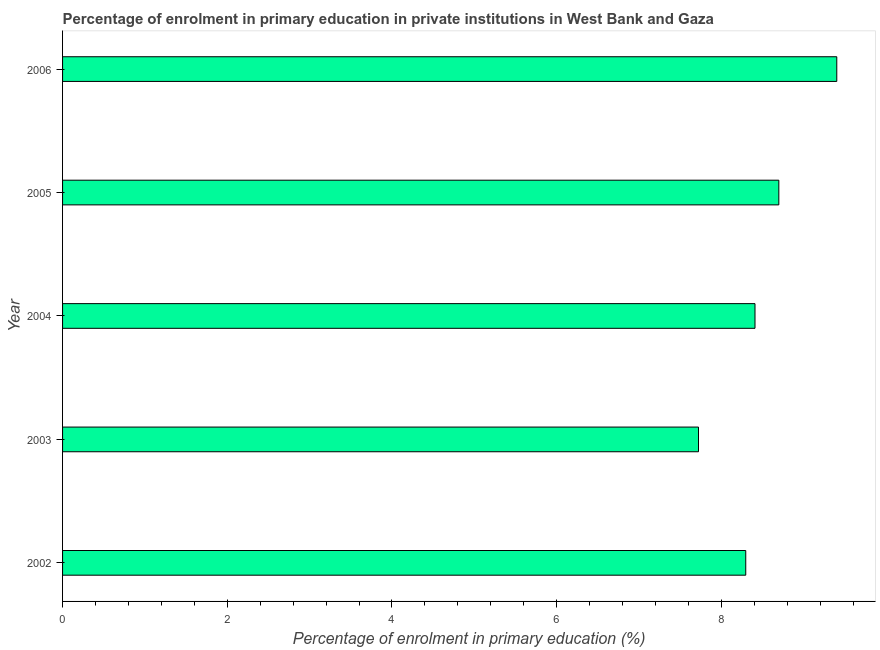Does the graph contain any zero values?
Your answer should be compact. No. What is the title of the graph?
Offer a very short reply. Percentage of enrolment in primary education in private institutions in West Bank and Gaza. What is the label or title of the X-axis?
Provide a succinct answer. Percentage of enrolment in primary education (%). What is the enrolment percentage in primary education in 2002?
Your answer should be very brief. 8.3. Across all years, what is the maximum enrolment percentage in primary education?
Provide a succinct answer. 9.4. Across all years, what is the minimum enrolment percentage in primary education?
Offer a very short reply. 7.72. In which year was the enrolment percentage in primary education maximum?
Your response must be concise. 2006. What is the sum of the enrolment percentage in primary education?
Give a very brief answer. 42.53. What is the difference between the enrolment percentage in primary education in 2003 and 2004?
Keep it short and to the point. -0.69. What is the average enrolment percentage in primary education per year?
Your answer should be very brief. 8.51. What is the median enrolment percentage in primary education?
Keep it short and to the point. 8.41. In how many years, is the enrolment percentage in primary education greater than 2.4 %?
Your answer should be compact. 5. Do a majority of the years between 2002 and 2006 (inclusive) have enrolment percentage in primary education greater than 8 %?
Provide a short and direct response. Yes. What is the ratio of the enrolment percentage in primary education in 2002 to that in 2005?
Provide a succinct answer. 0.95. Is the enrolment percentage in primary education in 2002 less than that in 2005?
Your answer should be compact. Yes. Is the difference between the enrolment percentage in primary education in 2003 and 2004 greater than the difference between any two years?
Offer a terse response. No. What is the difference between the highest and the second highest enrolment percentage in primary education?
Make the answer very short. 0.7. Is the sum of the enrolment percentage in primary education in 2002 and 2003 greater than the maximum enrolment percentage in primary education across all years?
Give a very brief answer. Yes. What is the difference between the highest and the lowest enrolment percentage in primary education?
Your response must be concise. 1.68. Are all the bars in the graph horizontal?
Provide a short and direct response. Yes. How many years are there in the graph?
Give a very brief answer. 5. What is the difference between two consecutive major ticks on the X-axis?
Your response must be concise. 2. What is the Percentage of enrolment in primary education (%) of 2002?
Your answer should be very brief. 8.3. What is the Percentage of enrolment in primary education (%) in 2003?
Provide a succinct answer. 7.72. What is the Percentage of enrolment in primary education (%) of 2004?
Ensure brevity in your answer.  8.41. What is the Percentage of enrolment in primary education (%) of 2005?
Make the answer very short. 8.7. What is the Percentage of enrolment in primary education (%) of 2006?
Provide a succinct answer. 9.4. What is the difference between the Percentage of enrolment in primary education (%) in 2002 and 2003?
Make the answer very short. 0.57. What is the difference between the Percentage of enrolment in primary education (%) in 2002 and 2004?
Keep it short and to the point. -0.11. What is the difference between the Percentage of enrolment in primary education (%) in 2002 and 2005?
Your answer should be very brief. -0.4. What is the difference between the Percentage of enrolment in primary education (%) in 2002 and 2006?
Ensure brevity in your answer.  -1.11. What is the difference between the Percentage of enrolment in primary education (%) in 2003 and 2004?
Offer a terse response. -0.69. What is the difference between the Percentage of enrolment in primary education (%) in 2003 and 2005?
Keep it short and to the point. -0.98. What is the difference between the Percentage of enrolment in primary education (%) in 2003 and 2006?
Your answer should be compact. -1.68. What is the difference between the Percentage of enrolment in primary education (%) in 2004 and 2005?
Offer a very short reply. -0.29. What is the difference between the Percentage of enrolment in primary education (%) in 2004 and 2006?
Your response must be concise. -0.99. What is the difference between the Percentage of enrolment in primary education (%) in 2005 and 2006?
Your answer should be compact. -0.7. What is the ratio of the Percentage of enrolment in primary education (%) in 2002 to that in 2003?
Your response must be concise. 1.07. What is the ratio of the Percentage of enrolment in primary education (%) in 2002 to that in 2004?
Make the answer very short. 0.99. What is the ratio of the Percentage of enrolment in primary education (%) in 2002 to that in 2005?
Your response must be concise. 0.95. What is the ratio of the Percentage of enrolment in primary education (%) in 2002 to that in 2006?
Offer a terse response. 0.88. What is the ratio of the Percentage of enrolment in primary education (%) in 2003 to that in 2004?
Ensure brevity in your answer.  0.92. What is the ratio of the Percentage of enrolment in primary education (%) in 2003 to that in 2005?
Your answer should be very brief. 0.89. What is the ratio of the Percentage of enrolment in primary education (%) in 2003 to that in 2006?
Give a very brief answer. 0.82. What is the ratio of the Percentage of enrolment in primary education (%) in 2004 to that in 2006?
Your answer should be very brief. 0.89. What is the ratio of the Percentage of enrolment in primary education (%) in 2005 to that in 2006?
Provide a short and direct response. 0.93. 